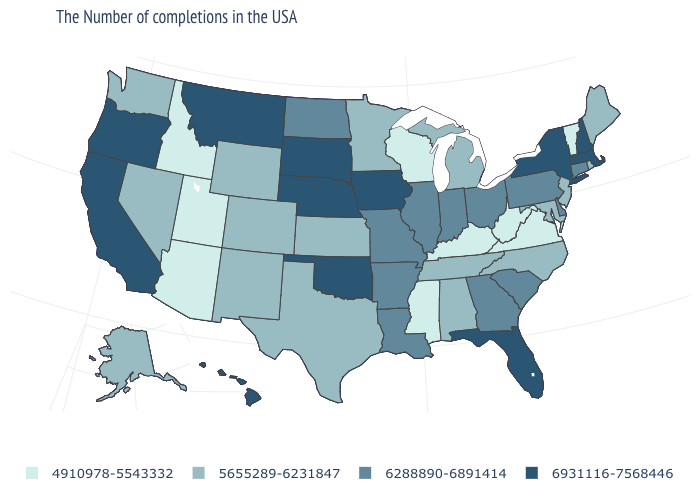What is the lowest value in the West?
Short answer required. 4910978-5543332. What is the value of North Dakota?
Write a very short answer. 6288890-6891414. What is the value of North Carolina?
Short answer required. 5655289-6231847. Does the first symbol in the legend represent the smallest category?
Short answer required. Yes. Which states have the lowest value in the USA?
Answer briefly. Vermont, Virginia, West Virginia, Kentucky, Wisconsin, Mississippi, Utah, Arizona, Idaho. Is the legend a continuous bar?
Concise answer only. No. Among the states that border North Dakota , does Montana have the highest value?
Short answer required. Yes. Name the states that have a value in the range 5655289-6231847?
Answer briefly. Maine, Rhode Island, New Jersey, Maryland, North Carolina, Michigan, Alabama, Tennessee, Minnesota, Kansas, Texas, Wyoming, Colorado, New Mexico, Nevada, Washington, Alaska. Name the states that have a value in the range 5655289-6231847?
Write a very short answer. Maine, Rhode Island, New Jersey, Maryland, North Carolina, Michigan, Alabama, Tennessee, Minnesota, Kansas, Texas, Wyoming, Colorado, New Mexico, Nevada, Washington, Alaska. Does the first symbol in the legend represent the smallest category?
Short answer required. Yes. What is the value of Ohio?
Quick response, please. 6288890-6891414. What is the lowest value in states that border Oklahoma?
Short answer required. 5655289-6231847. What is the value of Iowa?
Be succinct. 6931116-7568446. What is the value of West Virginia?
Keep it brief. 4910978-5543332. How many symbols are there in the legend?
Be succinct. 4. 